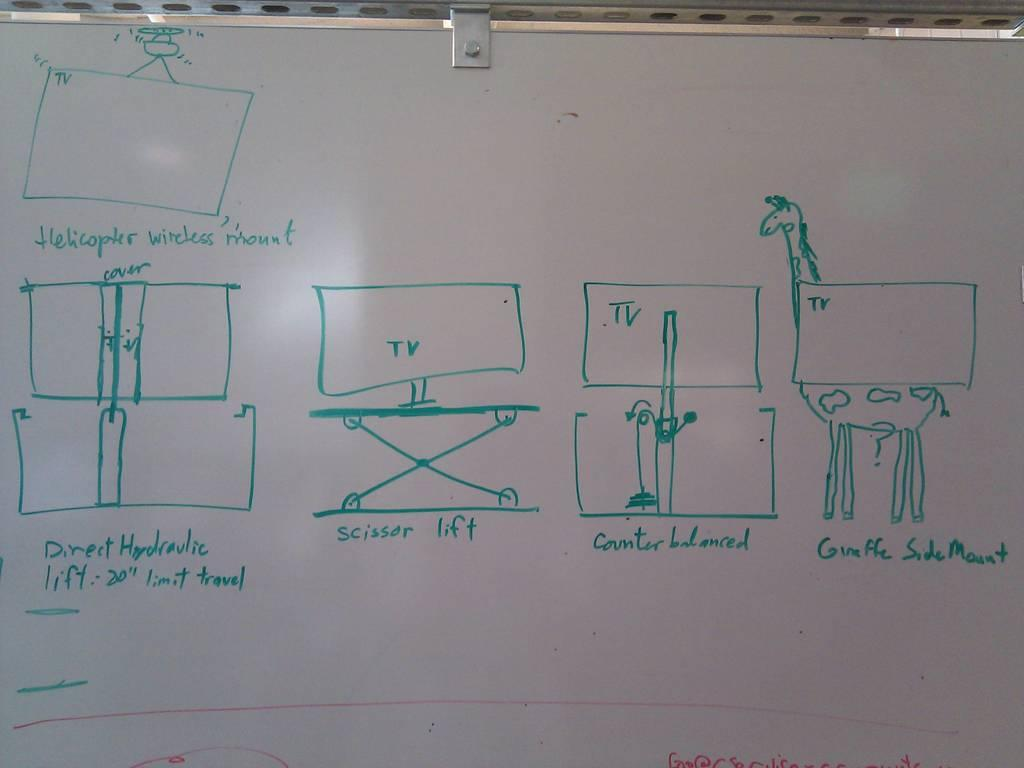<image>
Give a short and clear explanation of the subsequent image. A whiteboard with several diagrams of TVs on it 